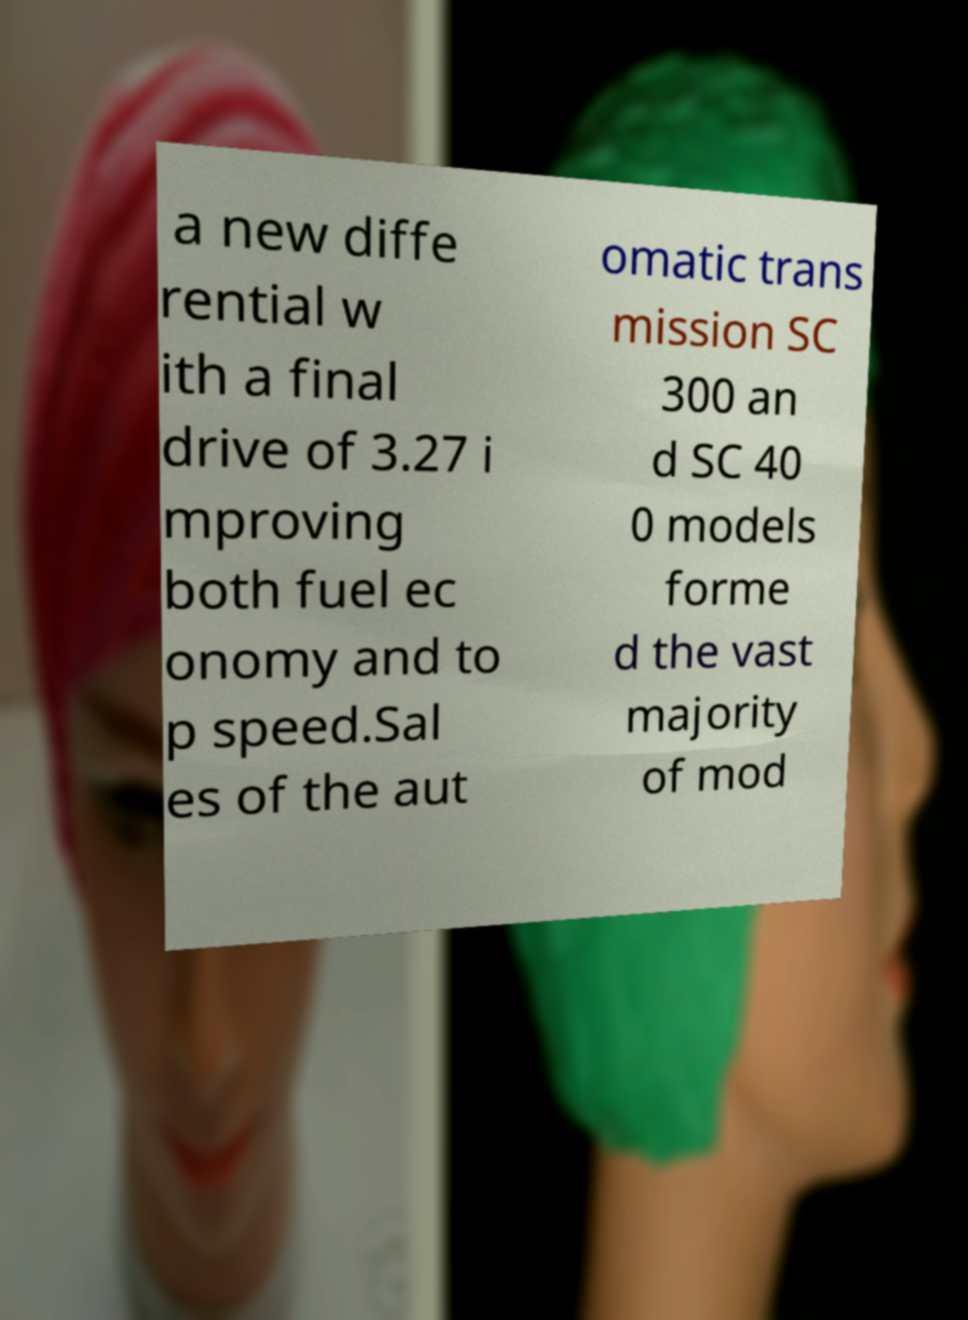Please identify and transcribe the text found in this image. a new diffe rential w ith a final drive of 3.27 i mproving both fuel ec onomy and to p speed.Sal es of the aut omatic trans mission SC 300 an d SC 40 0 models forme d the vast majority of mod 